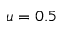<formula> <loc_0><loc_0><loc_500><loc_500>u = 0 . 5</formula> 